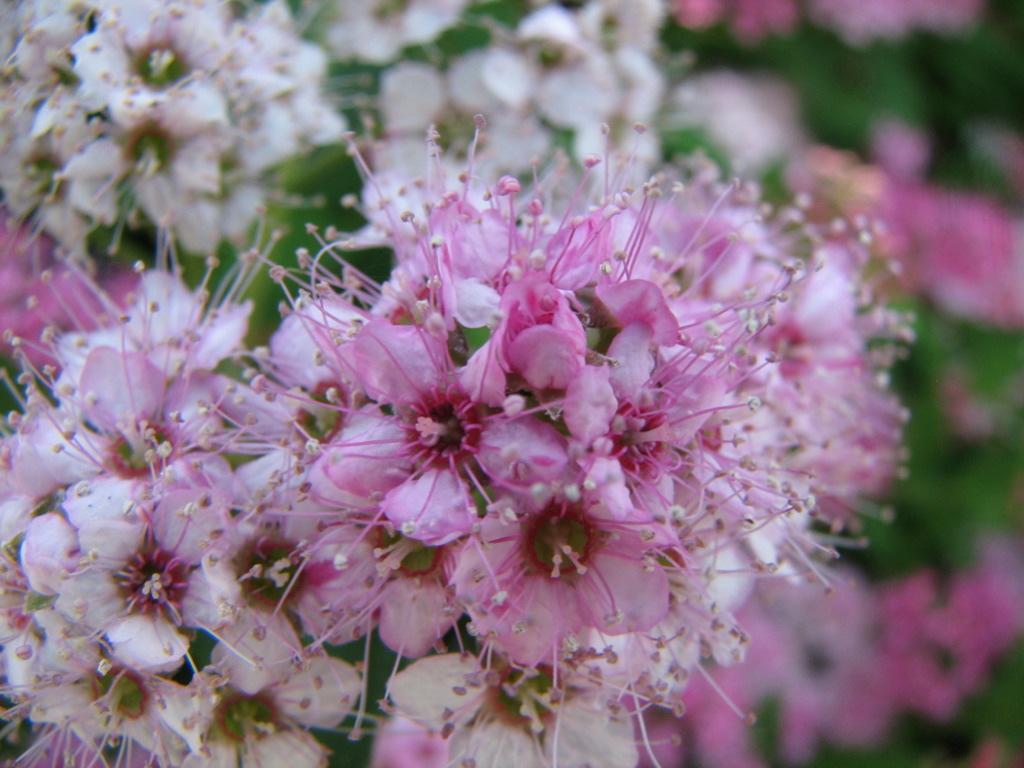Please provide a concise description of this image. In this image we can see bunch of pink and white color flowers. 